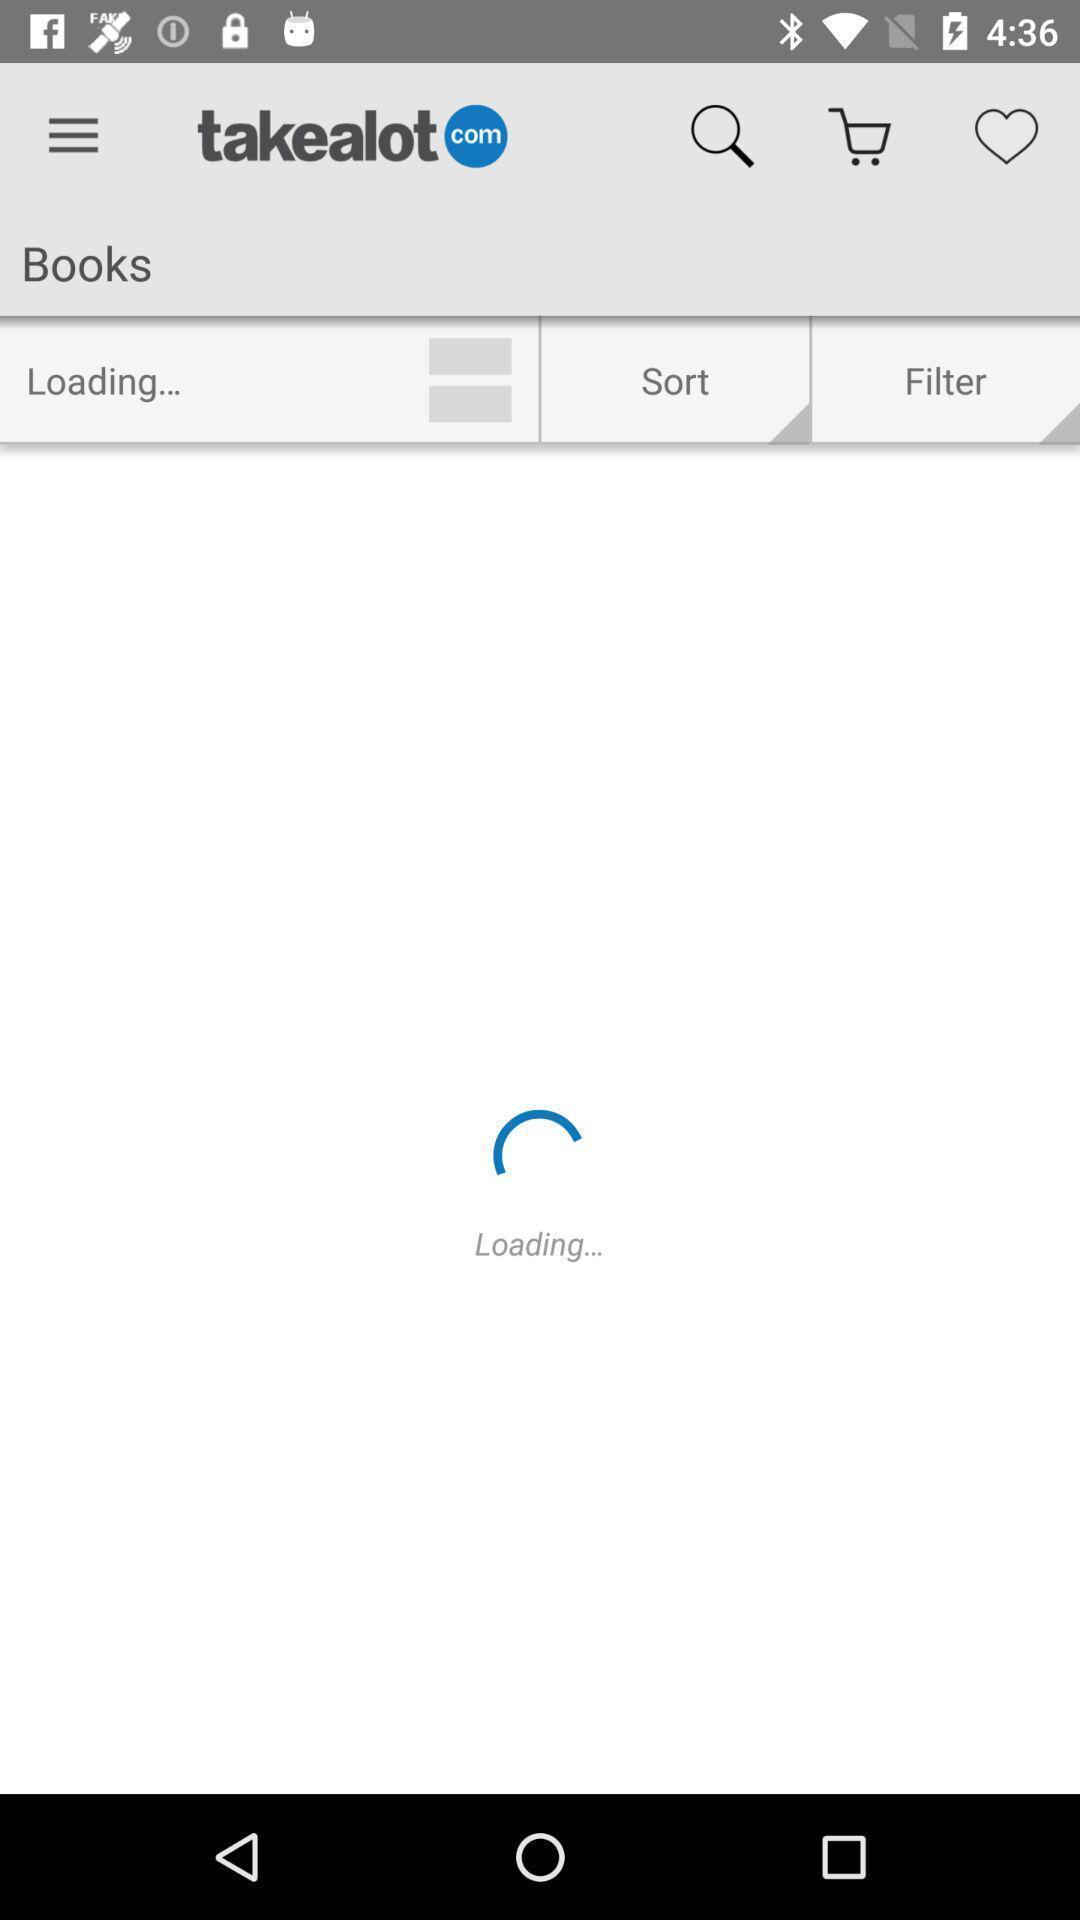Explain the elements present in this screenshot. Screen displaying multiple options in a shopping application. 